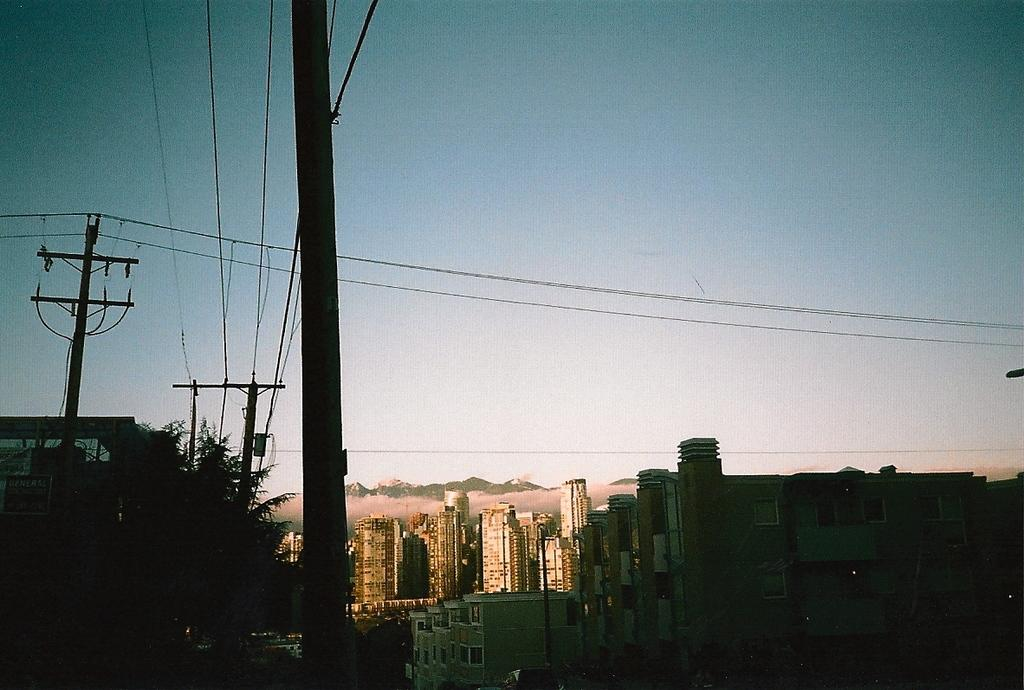What type of structures are located in the front of the image? There are buildings in the front of the image. What can be seen on the left side of the image? There is a tree and an electric pole on the left side of the image. What is connected to the electric pole in the image? There are cables associated with the electric pole in the image. What is visible at the top of the image? The sky is visible at the top of the image. Can you see any ghosts interacting with the tree on the left side of the image? There are no ghosts present in the image; it only features buildings, a tree, an electric pole, cables, and the sky. What type of thrill can be experienced by climbing the electric pole in the image? There is no indication that anyone is climbing the electric pole, and it is not advisable to do so for safety reasons. 